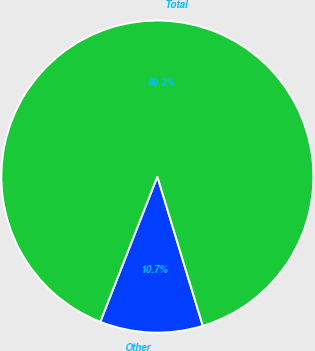<chart> <loc_0><loc_0><loc_500><loc_500><pie_chart><fcel>Other<fcel>Total<nl><fcel>10.66%<fcel>89.34%<nl></chart> 